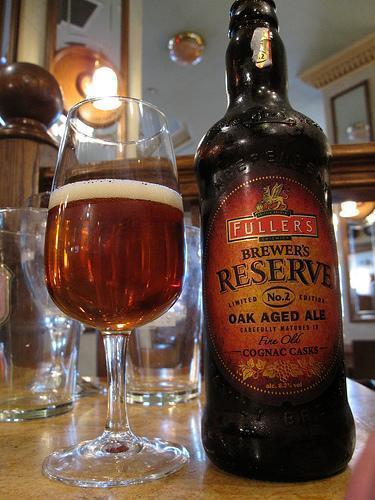How many beer bottles are shown?
Give a very brief answer. 1. 